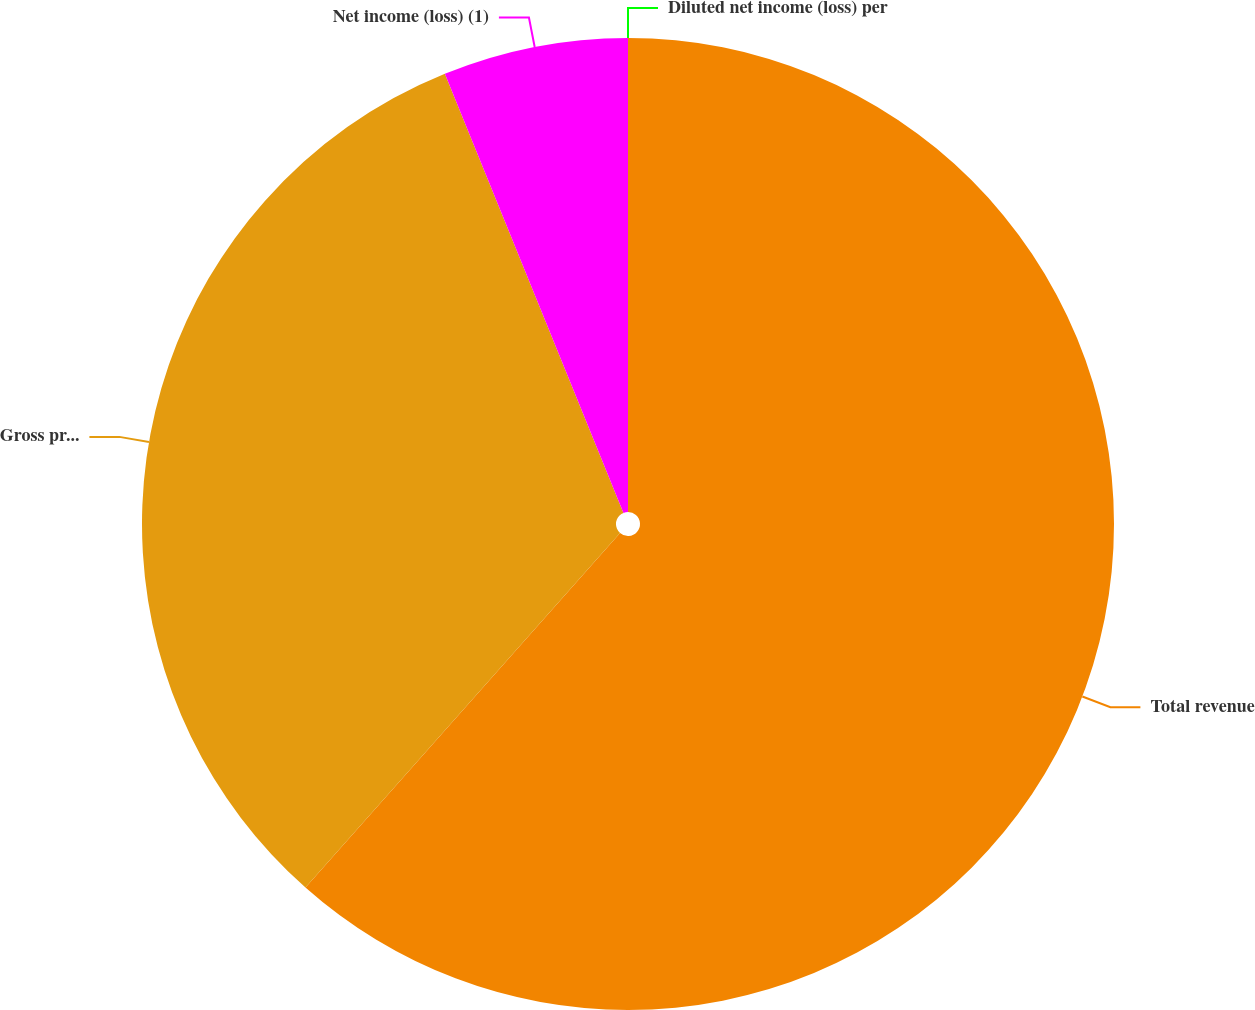<chart> <loc_0><loc_0><loc_500><loc_500><pie_chart><fcel>Total revenue<fcel>Gross profit (1)<fcel>Net income (loss) (1)<fcel>Diluted net income (loss) per<nl><fcel>61.55%<fcel>32.3%<fcel>6.15%<fcel>0.0%<nl></chart> 